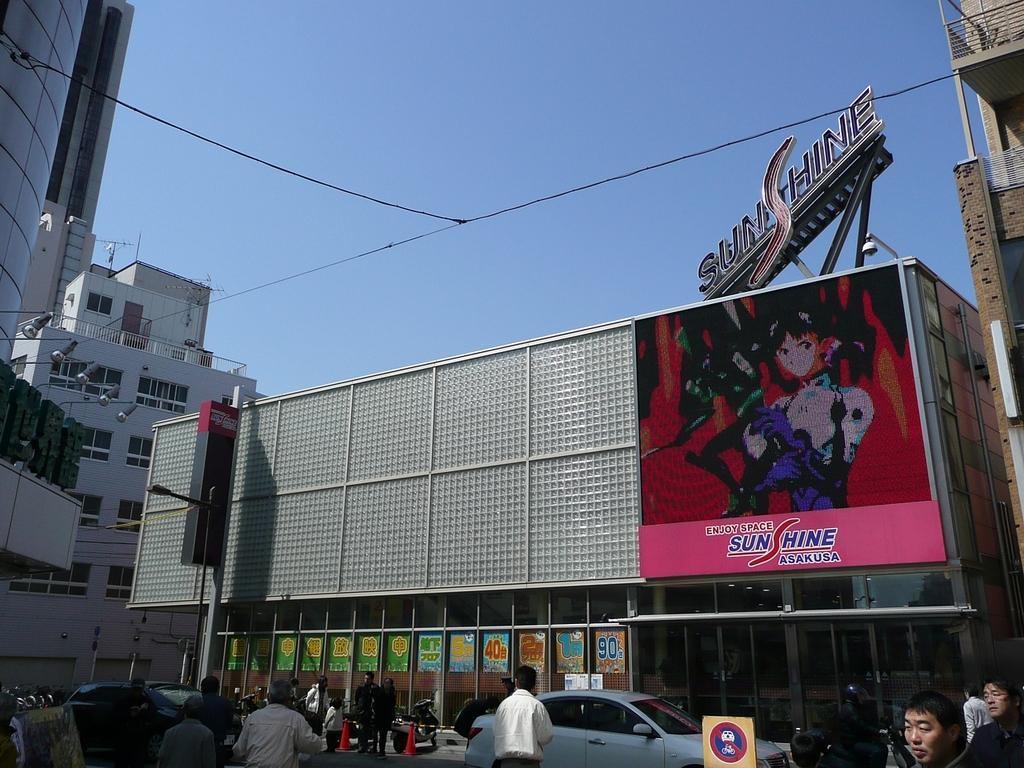Please provide a concise description of this image. In this image I can see few people and few vehicles on the road. Back IN case a buildings,windows,lights and a signboards. We can see a banner is attached to the building. The sky is in blue color. 